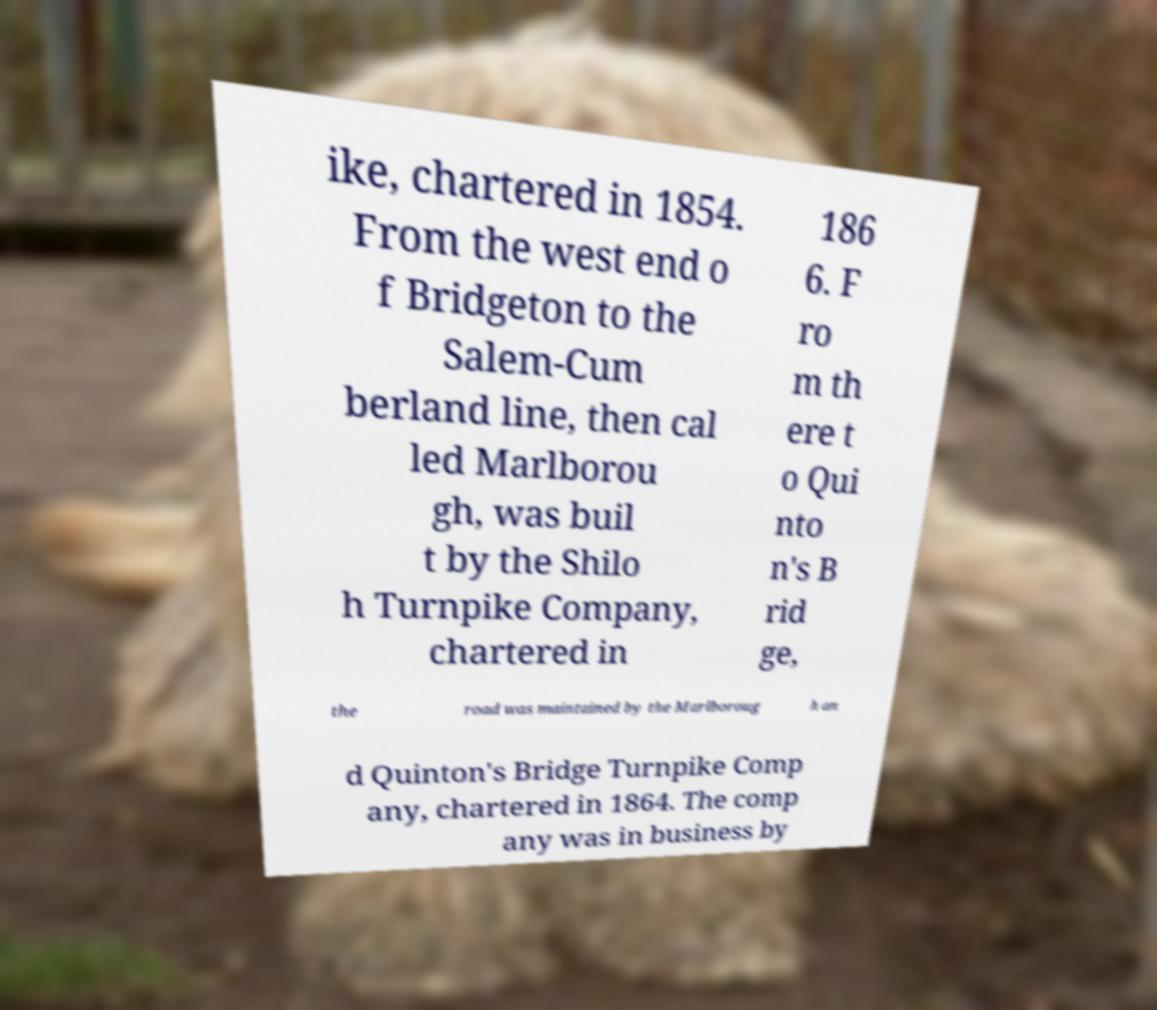Can you read and provide the text displayed in the image?This photo seems to have some interesting text. Can you extract and type it out for me? ike, chartered in 1854. From the west end o f Bridgeton to the Salem-Cum berland line, then cal led Marlborou gh, was buil t by the Shilo h Turnpike Company, chartered in 186 6. F ro m th ere t o Qui nto n's B rid ge, the road was maintained by the Marlboroug h an d Quinton's Bridge Turnpike Comp any, chartered in 1864. The comp any was in business by 